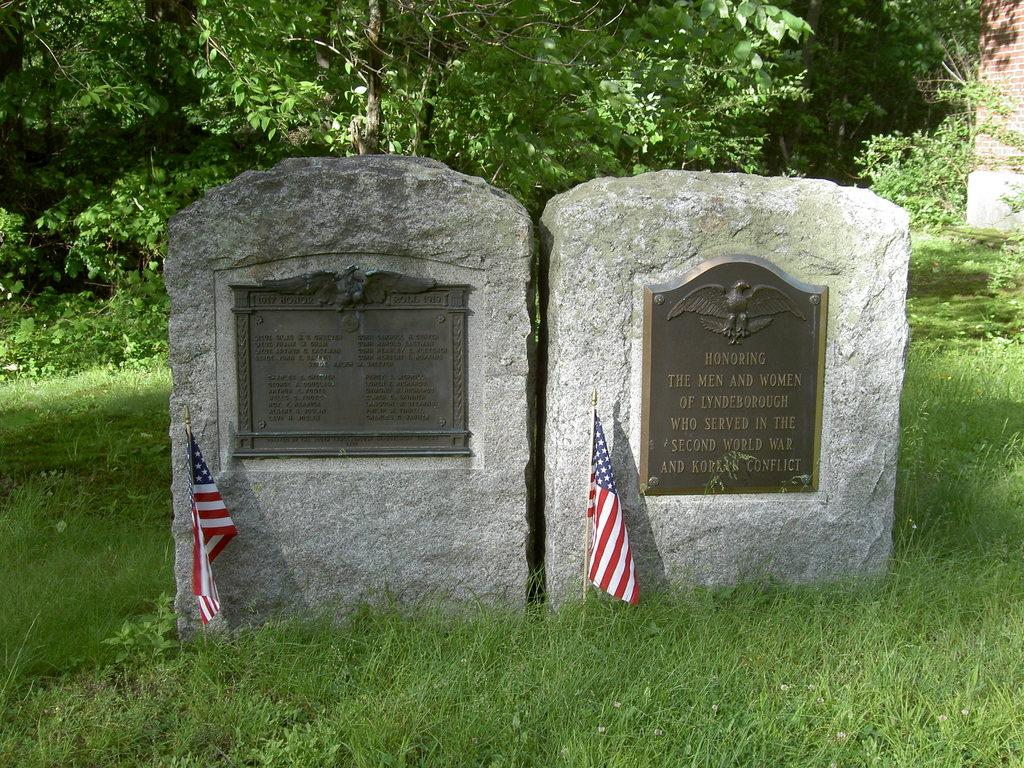What can be seen on the two boards in the image? There are two boards with text in the image. What is located in front of the poles in the image? There are two flags in front of poles in the image. What type of vegetation is visible in the image? There are trees and grass visible in the image. What type of structure can be seen in the image? There is a wall in the image. How many chairs are placed around the pizzas in the image? There are no chairs or pizzas present in the image. What news is being reported on the flags in the image? The flags in the image do not have any text or news; they are simply flags on poles. 